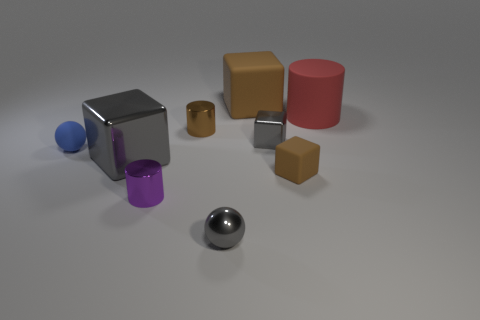There is a red cylinder that is made of the same material as the tiny blue sphere; what is its size?
Your answer should be very brief. Large. There is a large red object; are there any small brown cylinders behind it?
Ensure brevity in your answer.  No. Is the brown metallic object the same shape as the red matte thing?
Give a very brief answer. Yes. How big is the brown thing in front of the gray block that is to the left of the object behind the red object?
Give a very brief answer. Small. What material is the blue object?
Your answer should be very brief. Rubber. What is the size of the shiny ball that is the same color as the large shiny block?
Ensure brevity in your answer.  Small. Is the shape of the big brown matte object the same as the tiny brown thing that is behind the big metal thing?
Ensure brevity in your answer.  No. What material is the big block left of the small gray object that is in front of the tiny brown cube that is to the left of the large red object?
Provide a short and direct response. Metal. What number of brown matte cubes are there?
Offer a terse response. 2. How many yellow things are either big matte objects or spheres?
Provide a short and direct response. 0. 